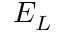Convert formula to latex. <formula><loc_0><loc_0><loc_500><loc_500>E _ { L }</formula> 